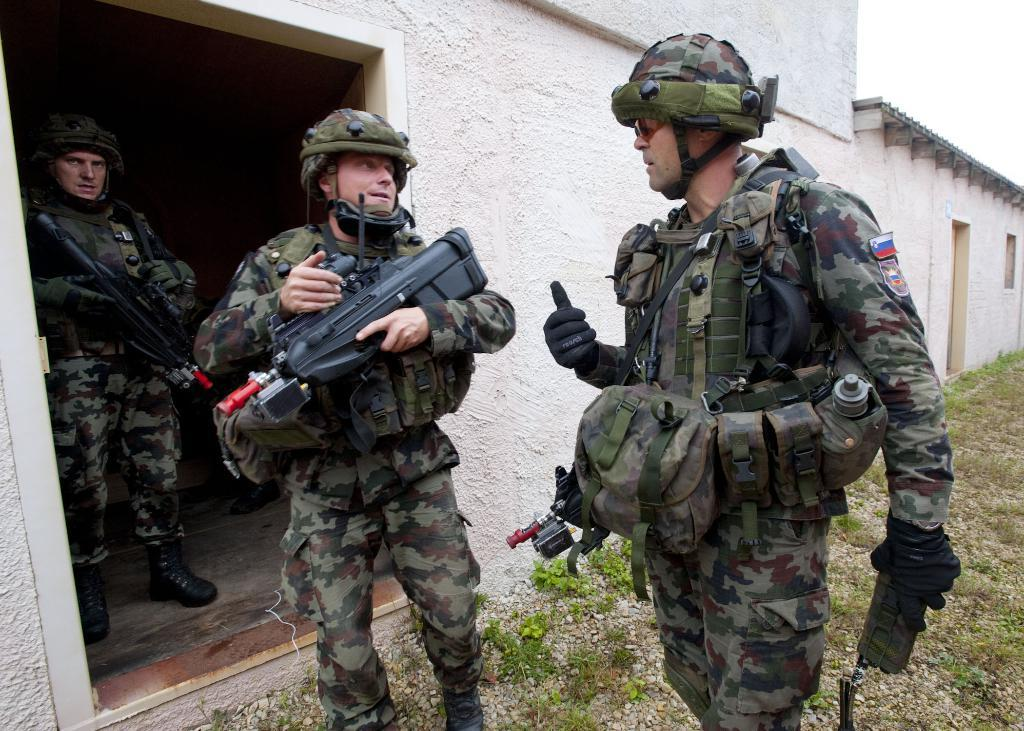How many persons are visible in the background of the image? There are three persons in the background of the image. What are the persons wearing? The persons are wearing army uniforms and helmets. What are the persons holding? The persons are holding weapons. What type of structures can be seen in the background of the image? There are houses in the background of the image. What is visible in the sky in the background of the image? The sky is visible in the background of the image. What type of produce is being harvested by the persons in the image? There is no produce or harvesting activity depicted in the image; the persons are wearing army uniforms and holding weapons. What color is the ship in the image? There is no ship present in the image. 